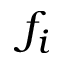<formula> <loc_0><loc_0><loc_500><loc_500>f _ { i }</formula> 